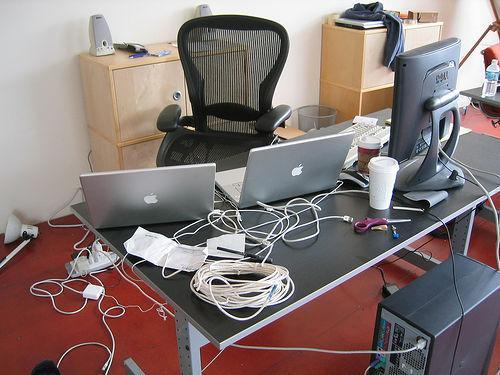How many chairs are there?
Give a very brief answer. 1. How many laptops are there?
Give a very brief answer. 2. How many chairs can be seen?
Give a very brief answer. 1. 